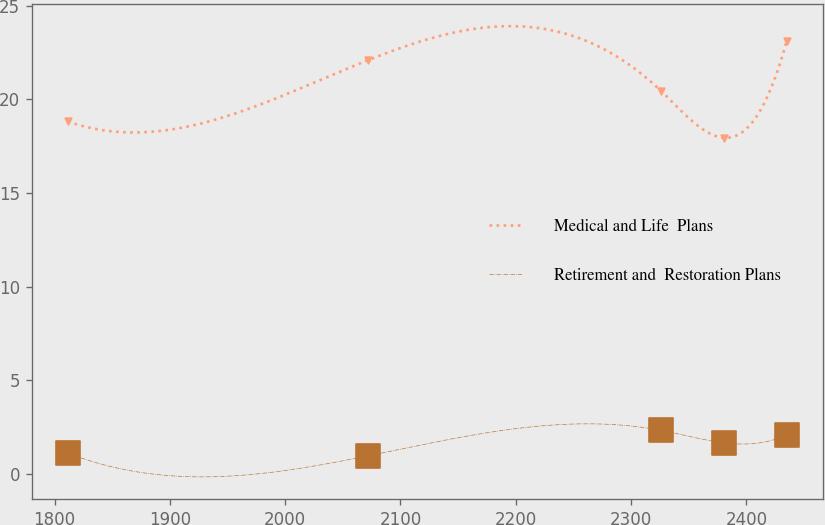<chart> <loc_0><loc_0><loc_500><loc_500><line_chart><ecel><fcel>Medical and Life  Plans<fcel>Retirement and  Restoration Plans<nl><fcel>1811.46<fcel>18.82<fcel>1.12<nl><fcel>2072.15<fcel>22.1<fcel>0.98<nl><fcel>2326.28<fcel>20.43<fcel>2.33<nl><fcel>2380.62<fcel>17.95<fcel>1.67<nl><fcel>2434.96<fcel>23.13<fcel>2.09<nl></chart> 